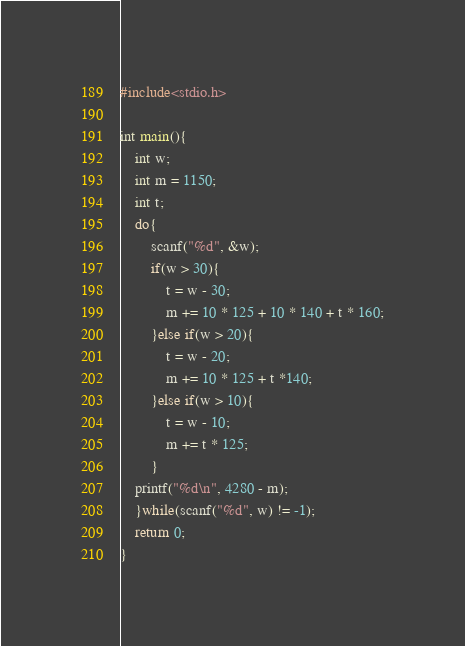Convert code to text. <code><loc_0><loc_0><loc_500><loc_500><_C_>#include<stdio.h>

int main(){
	int w;
	int m = 1150;
	int t;
	do{
		scanf("%d", &w);		
		if(w > 30){
			t = w - 30;
			m += 10 * 125 + 10 * 140 + t * 160;
		}else if(w > 20){
			t = w - 20;
			m += 10 * 125 + t *140;
		}else if(w > 10){
			t = w - 10;
			m += t * 125;
		}
	printf("%d\n", 4280 - m);
	}while(scanf("%d", w) != -1);
	return 0;
}</code> 